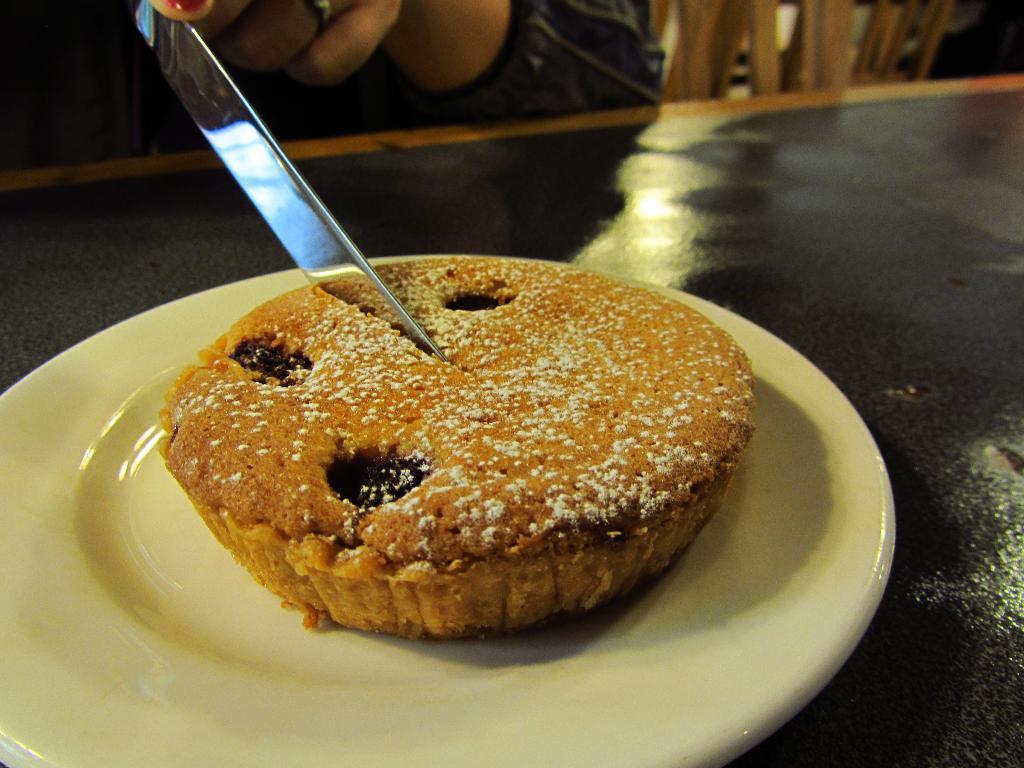Can you describe this image briefly? In this picture I can observe some food places in the plate. It is looking like a cake. This plate is placed on the table. I can observe a knife cutting the cake. 